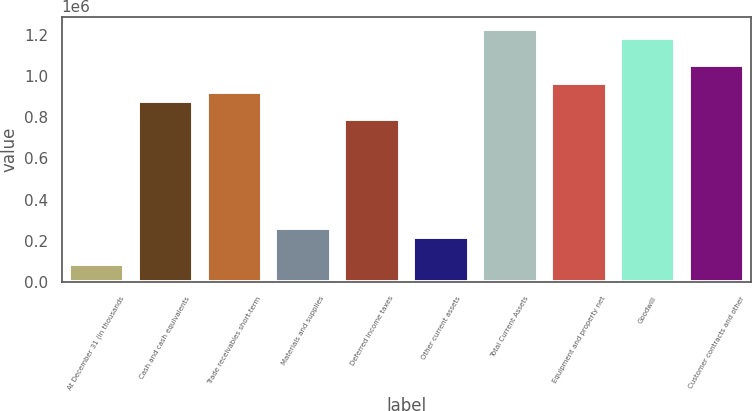Convert chart. <chart><loc_0><loc_0><loc_500><loc_500><bar_chart><fcel>At December 31 (in thousands<fcel>Cash and cash equivalents<fcel>Trade receivables short-term<fcel>Materials and supplies<fcel>Deferred income taxes<fcel>Other current assets<fcel>Total Current Assets<fcel>Equipment and property net<fcel>Goodwill<fcel>Customer contracts and other<nl><fcel>88132<fcel>876280<fcel>920066<fcel>263276<fcel>788708<fcel>219490<fcel>1.22657e+06<fcel>963852<fcel>1.18278e+06<fcel>1.05142e+06<nl></chart> 